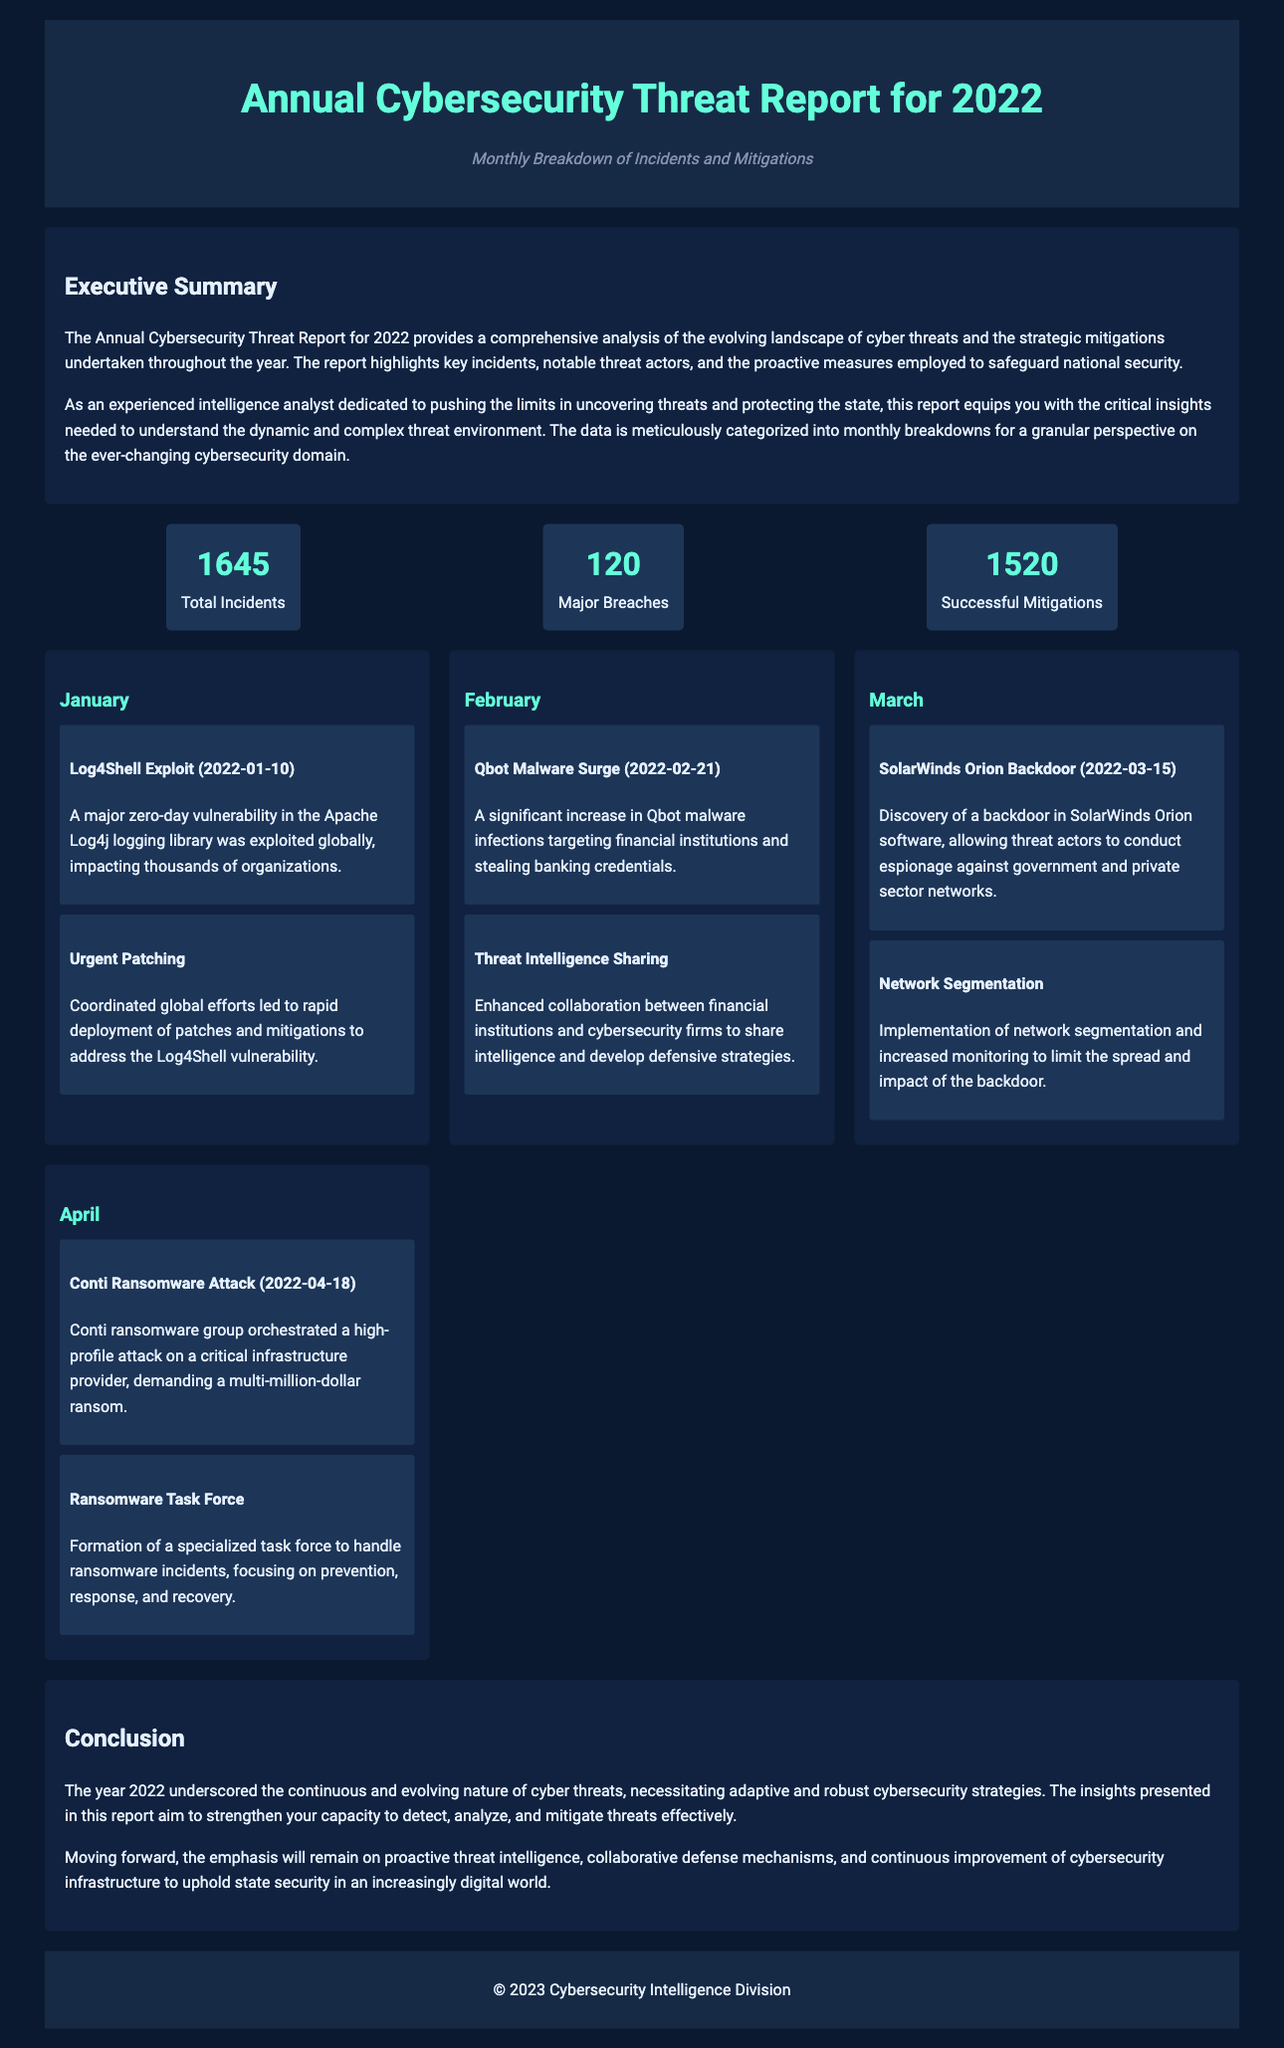What is the total number of incidents reported? The total number of incidents is mentioned directly in the statistics section of the document.
Answer: 1645 How many major breaches were recorded? The document specifies the number of major breaches in the statistics section.
Answer: 120 What was the notable exploit in January 2022? The document lists incidents for each month; January's significant exploit is highlighted.
Answer: Log4Shell Exploit What mitigation was implemented for the Qbot malware? The document describes specific mitigations for each incident, particularly for February's Qbot malware.
Answer: Threat Intelligence Sharing What was the total number of successful mitigations? The document includes this figure in the statistical summary.
Answer: 1520 Which month had a significant ransomware attack? Analyzing the incidents listed for each month points to the month with the major ransomware incident.
Answer: April What proactive measure was taken in response to the SolarWinds Orion backdoor? The mitigation related to the SolarWinds Orion incident is detailed in the monthly breakdown section.
Answer: Network Segmentation What type of report is this document categorized as? The title of the document indicates its classification, which also reflects its content focus.
Answer: Cybersecurity Threat Report What organization published the report? The footer of the document states the organization responsible for the report.
Answer: Cybersecurity Intelligence Division 